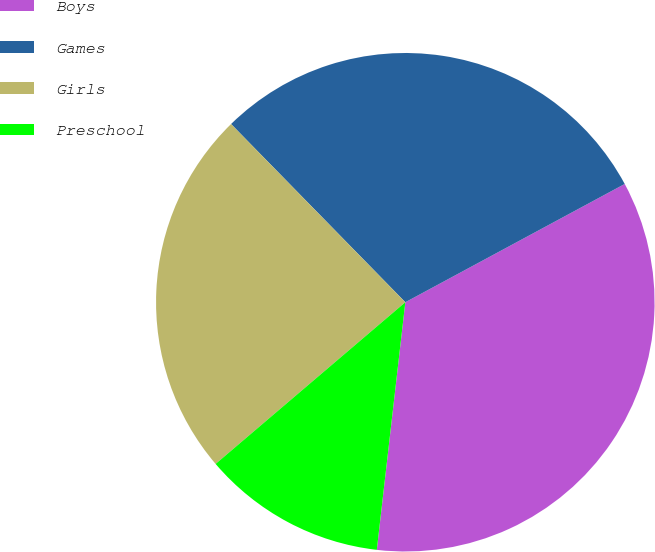Convert chart to OTSL. <chart><loc_0><loc_0><loc_500><loc_500><pie_chart><fcel>Boys<fcel>Games<fcel>Girls<fcel>Preschool<nl><fcel>34.69%<fcel>29.45%<fcel>23.91%<fcel>11.94%<nl></chart> 